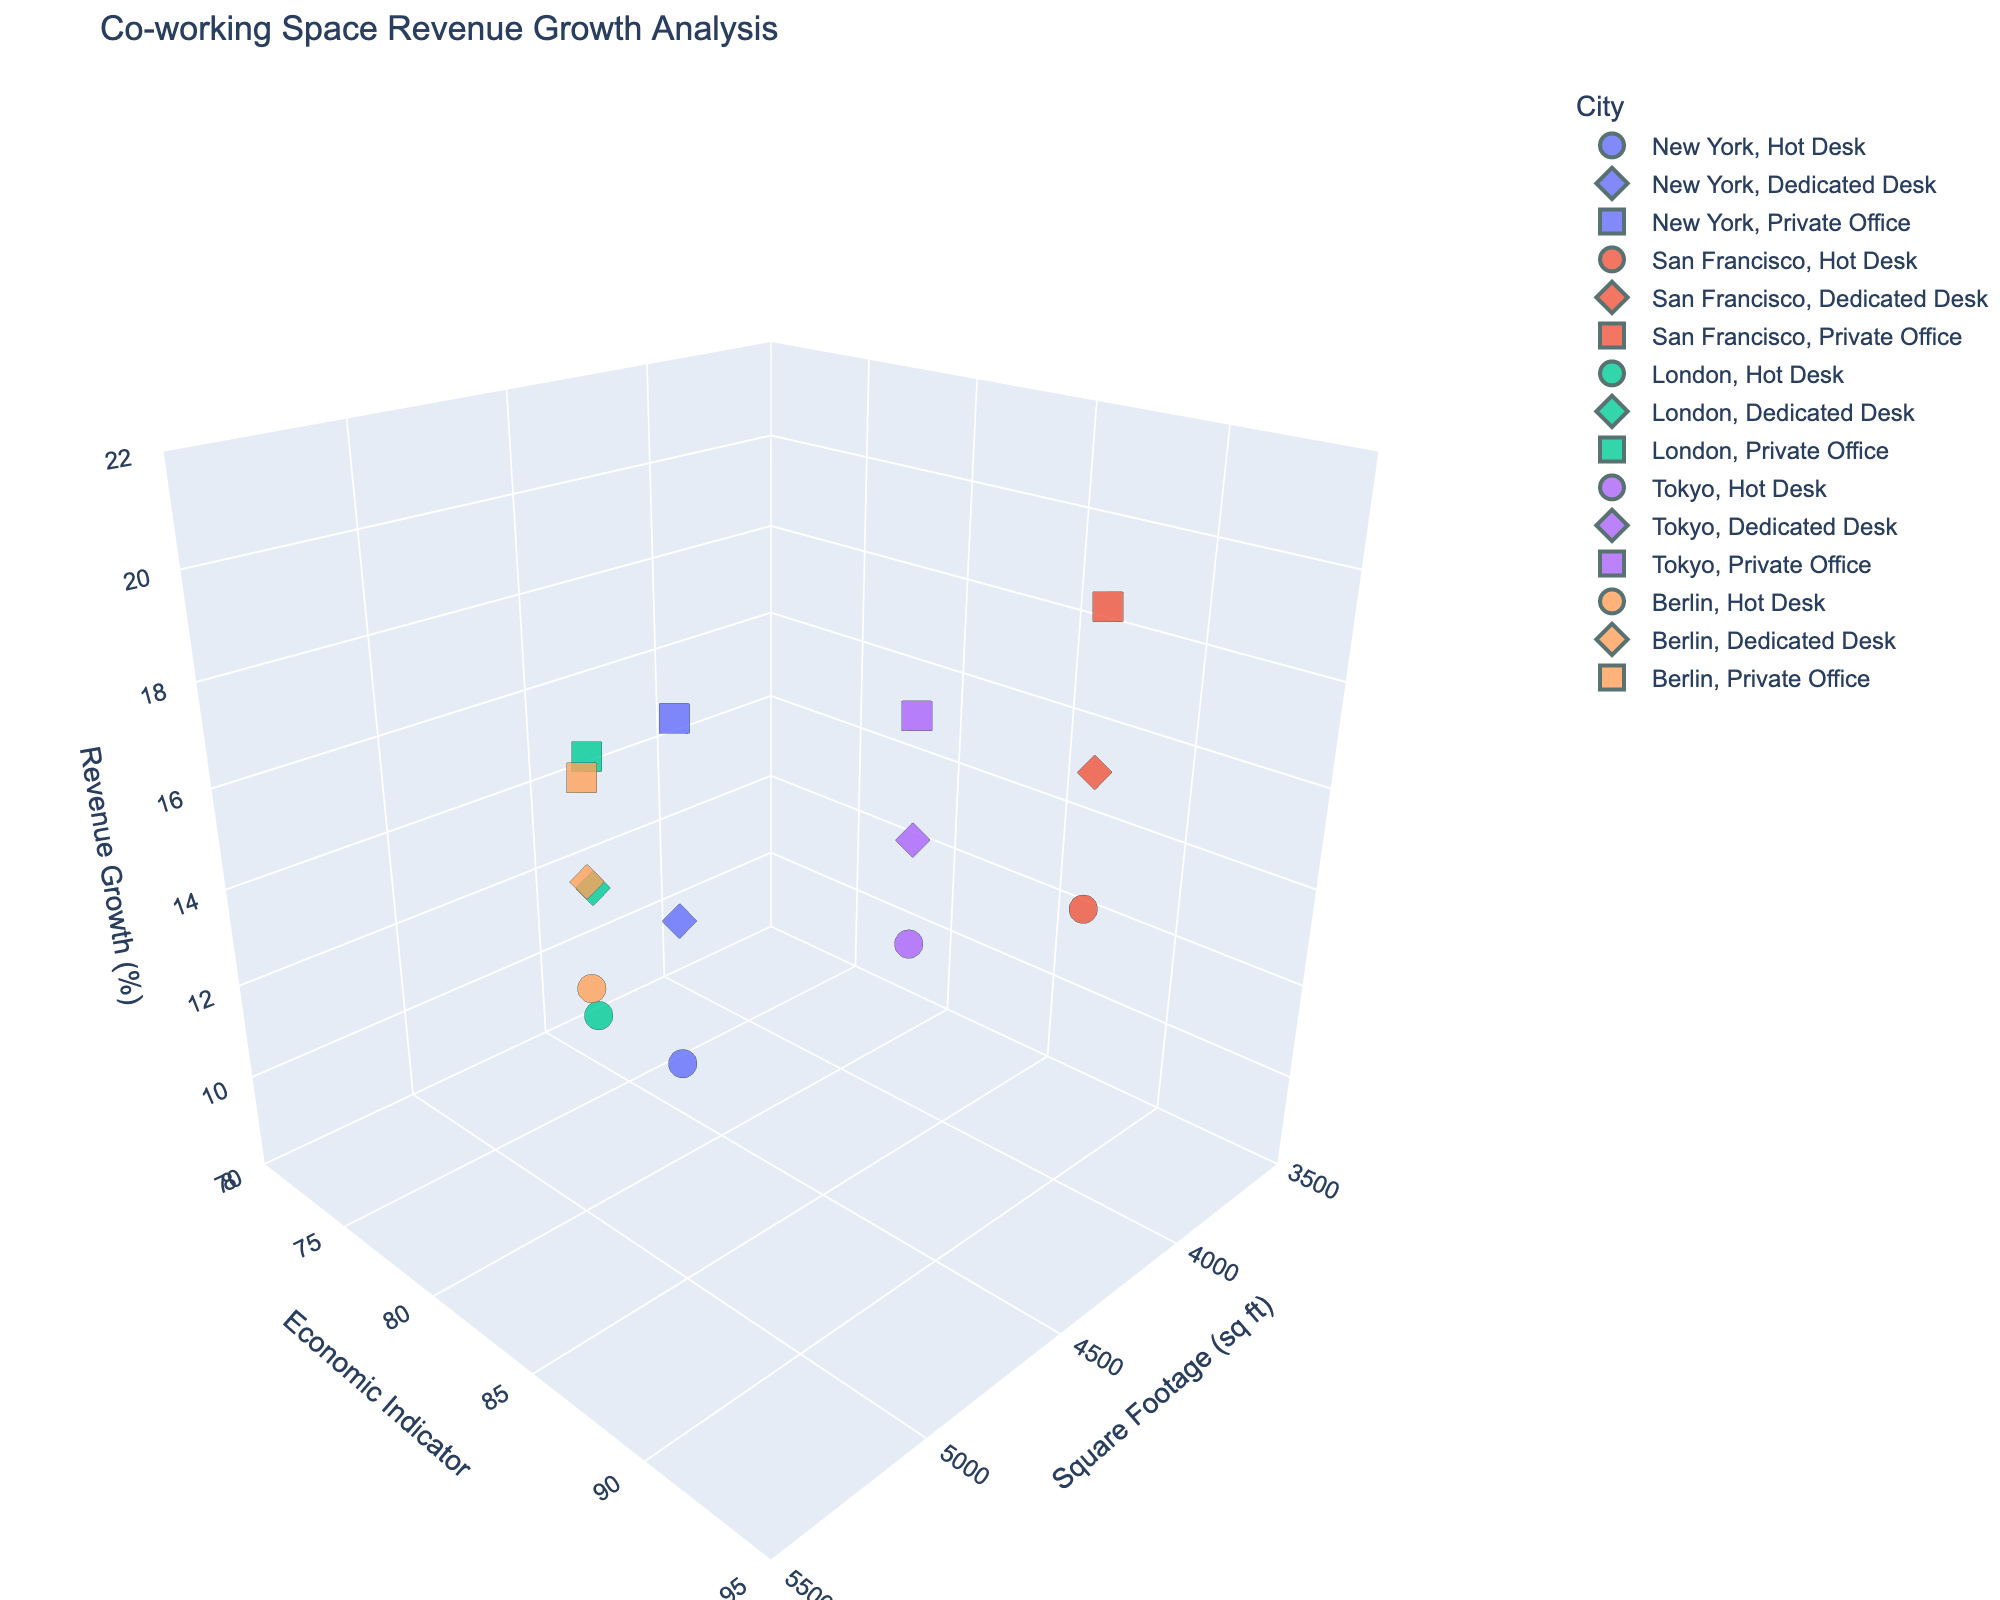What is the title of the plot? The title is displayed at the top of the figure and gives an overview of what the plot shows.
Answer: Co-working Space Revenue Growth Analysis How many cities are represented in the plot? The plot uses different colors to represent each city. By observing the legend, you can count the distinct colors corresponding to different cities.
Answer: 5 Which membership type shows the highest revenue growth in San Francisco? By examining the plotted symbols for San Francisco and comparing the 'Revenue Growth' values, you can identify the membership type with the highest value.
Answer: Private Office How does the local economic indicator in New York compare to that in Berlin? Compare the 'Local Economic Indicator' values for the data points in New York and Berlin, visible on the y-axis.
Answer: Higher in New York What's the difference in revenue growth between the highest and lowest membership types in Tokyo? Identify the highest and lowest 'Revenue Growth' values for Tokyo, then subtract the lower value from the higher one.
Answer: 5.1% What is the average square footage of co-working spaces across all cities? Add all the 'Square_Footage' values and divide by the total number of data points (15 data points in total).
Answer: 4386.67 sq ft In which city do hot desks have the highest revenue growth? Look at the revenue growth for hot desks across all cities and find the city with the highest value.
Answer: San Francisco Is there a correlation between square footage and revenue growth? Observe whether higher or lower square footage tends to correspond consistently with higher revenue growth on the x- and z-axes of the plot.
Answer: Not clear (The relationship does not show a clear pattern) Which membership type generally achieves higher revenue growth: Dedicated Desk or Hot Desk? Compare the 'Revenue Growth' values for Dedicated Desk and Hot Desk across all cities and assess which one tends to have higher values.
Answer: Dedicated Desk How does the economic indicator impact revenue growth in London compared to Berlin? Observe the 'Local_Economic_Indicator' and 'Revenue_Growth' for data points in London and Berlin to see if there's a relationship.
Answer: Higher economic indicator generally leads to higher revenue growth in London compared to Berlin 